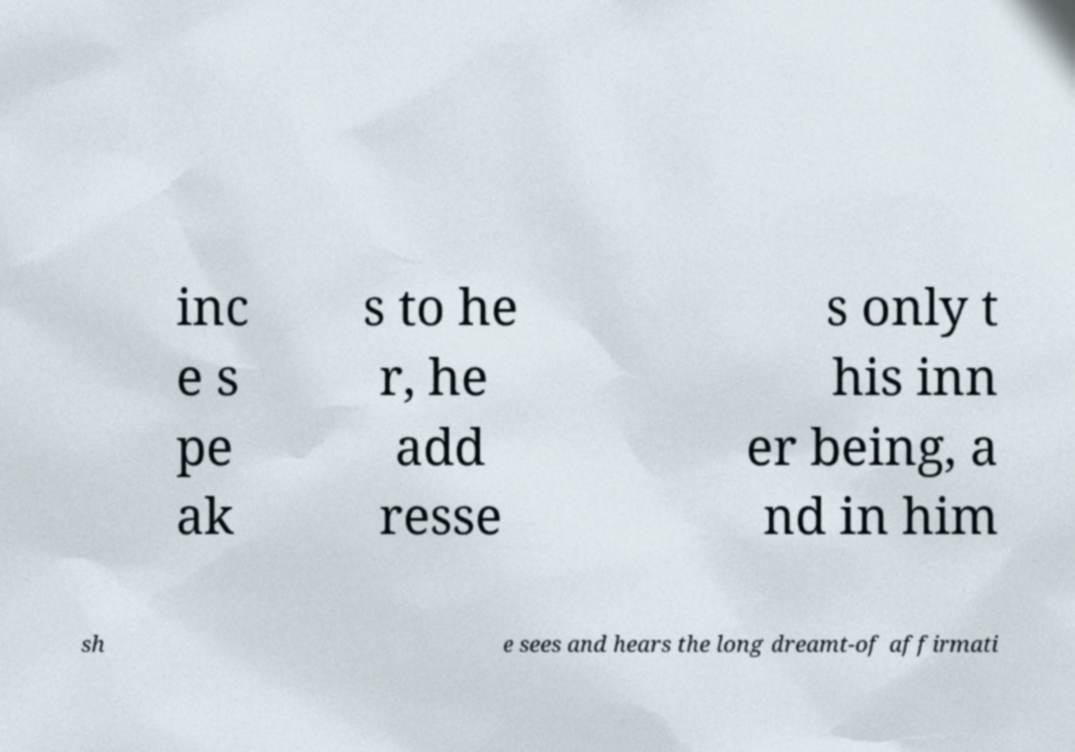Can you read and provide the text displayed in the image?This photo seems to have some interesting text. Can you extract and type it out for me? inc e s pe ak s to he r, he add resse s only t his inn er being, a nd in him sh e sees and hears the long dreamt-of affirmati 